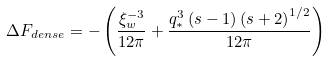<formula> <loc_0><loc_0><loc_500><loc_500>\Delta F _ { d e n s e } = - \left ( \frac { \xi _ { w } ^ { - 3 } } { 1 2 \pi } + \frac { q _ { \ast } ^ { 3 } \left ( s - 1 \right ) \left ( s + 2 \right ) ^ { 1 / 2 } } { 1 2 \pi } \right )</formula> 